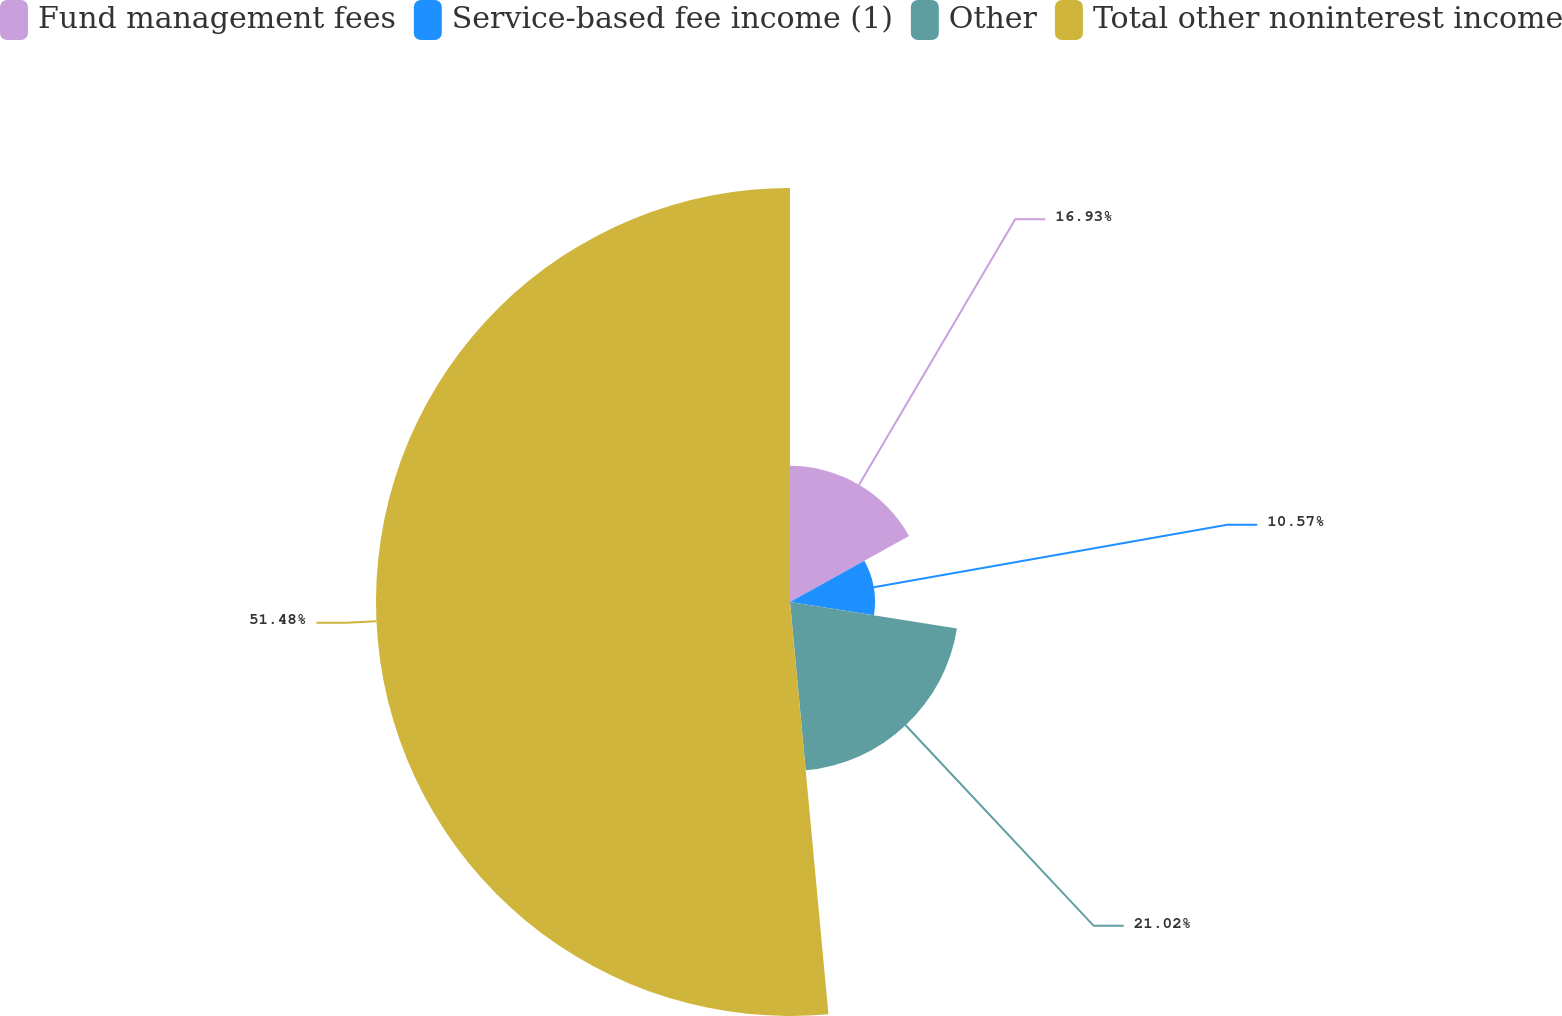<chart> <loc_0><loc_0><loc_500><loc_500><pie_chart><fcel>Fund management fees<fcel>Service-based fee income (1)<fcel>Other<fcel>Total other noninterest income<nl><fcel>16.93%<fcel>10.57%<fcel>21.02%<fcel>51.48%<nl></chart> 